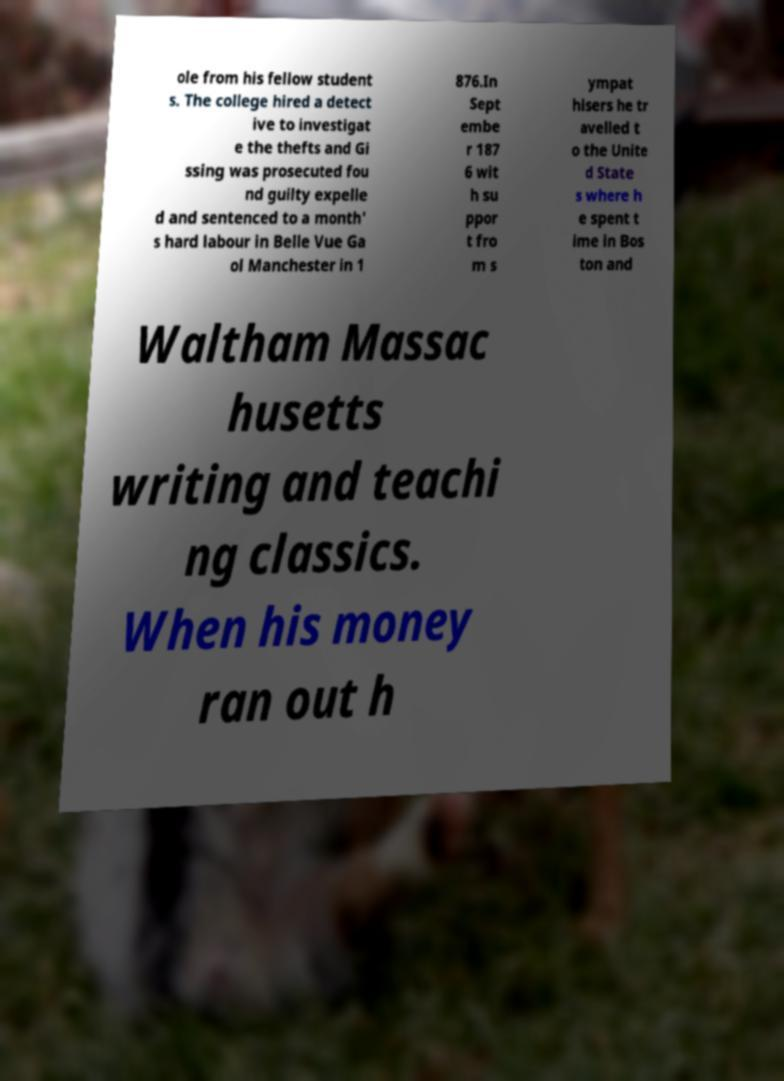Please read and relay the text visible in this image. What does it say? ole from his fellow student s. The college hired a detect ive to investigat e the thefts and Gi ssing was prosecuted fou nd guilty expelle d and sentenced to a month' s hard labour in Belle Vue Ga ol Manchester in 1 876.In Sept embe r 187 6 wit h su ppor t fro m s ympat hisers he tr avelled t o the Unite d State s where h e spent t ime in Bos ton and Waltham Massac husetts writing and teachi ng classics. When his money ran out h 